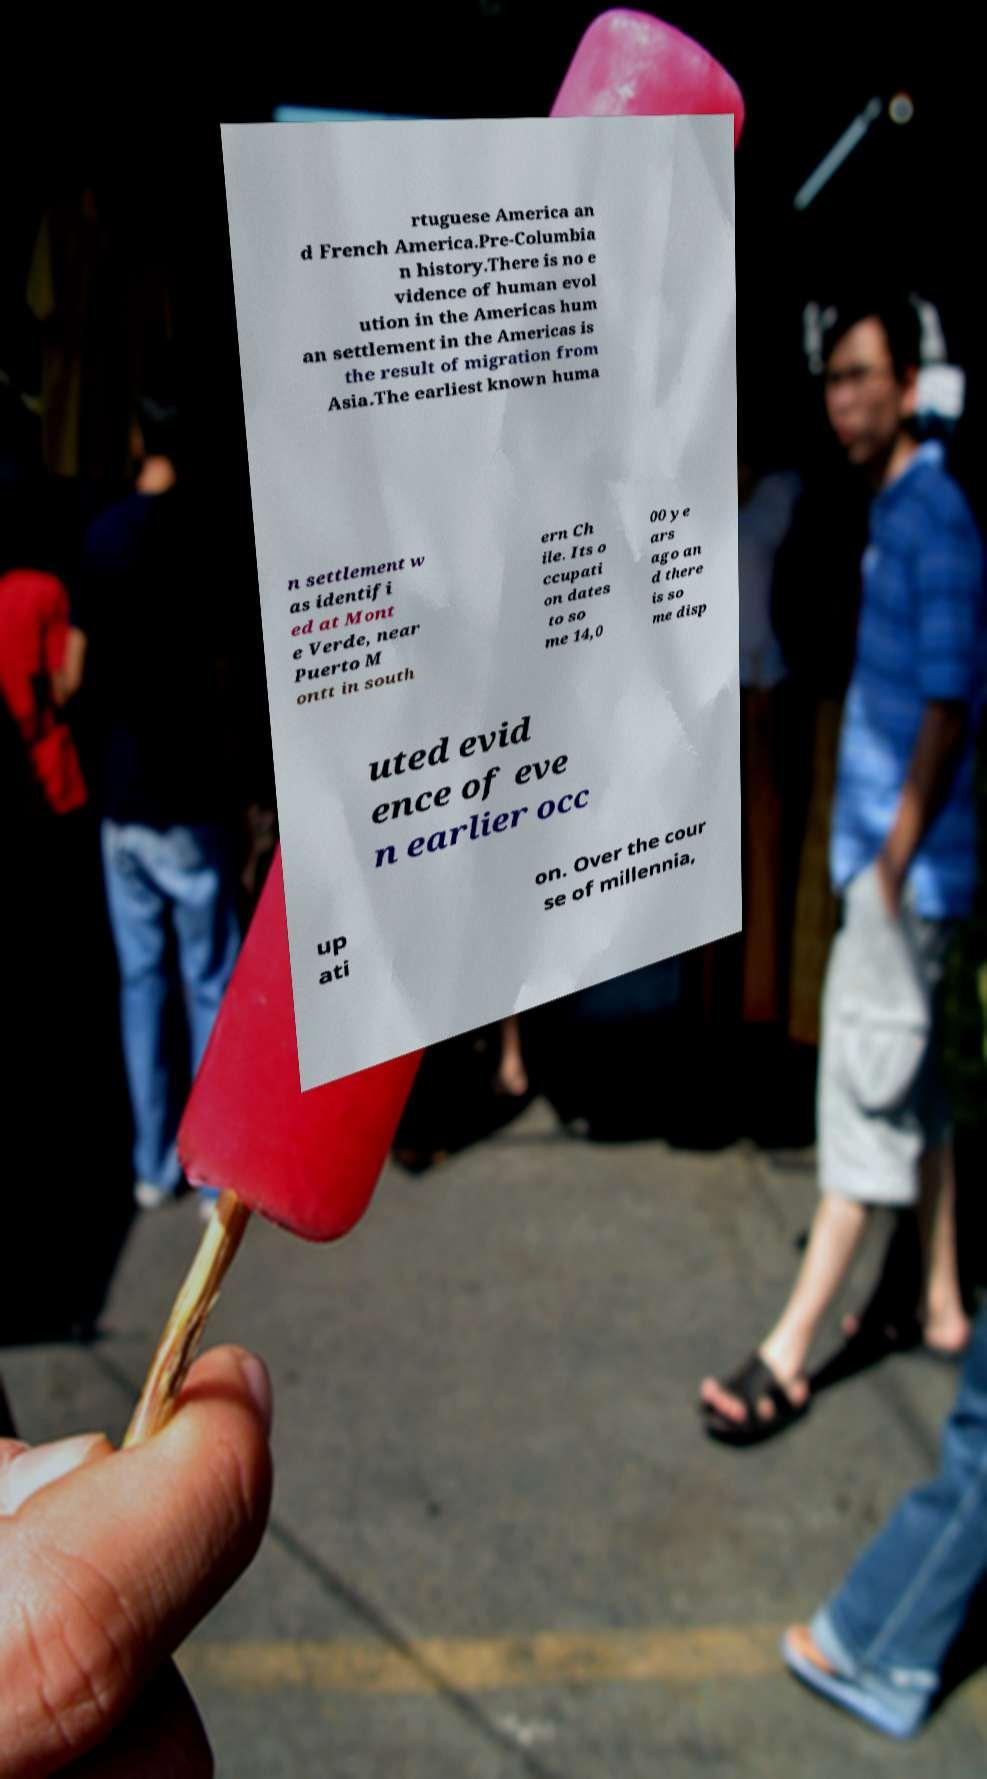For documentation purposes, I need the text within this image transcribed. Could you provide that? rtuguese America an d French America.Pre-Columbia n history.There is no e vidence of human evol ution in the Americas hum an settlement in the Americas is the result of migration from Asia.The earliest known huma n settlement w as identifi ed at Mont e Verde, near Puerto M ontt in south ern Ch ile. Its o ccupati on dates to so me 14,0 00 ye ars ago an d there is so me disp uted evid ence of eve n earlier occ up ati on. Over the cour se of millennia, 